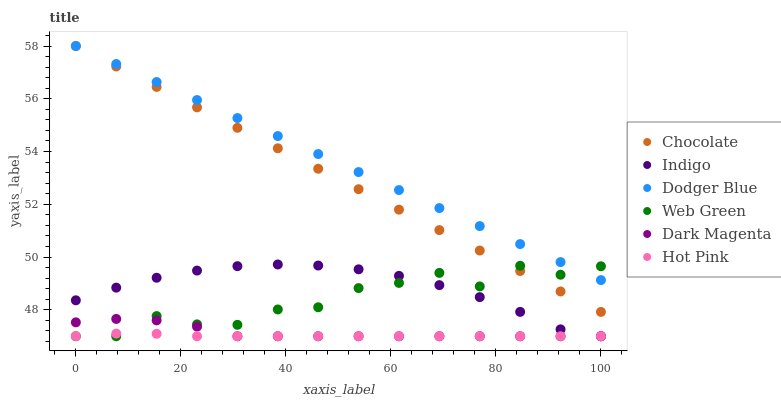Does Hot Pink have the minimum area under the curve?
Answer yes or no. Yes. Does Dodger Blue have the maximum area under the curve?
Answer yes or no. Yes. Does Dark Magenta have the minimum area under the curve?
Answer yes or no. No. Does Dark Magenta have the maximum area under the curve?
Answer yes or no. No. Is Dodger Blue the smoothest?
Answer yes or no. Yes. Is Web Green the roughest?
Answer yes or no. Yes. Is Dark Magenta the smoothest?
Answer yes or no. No. Is Dark Magenta the roughest?
Answer yes or no. No. Does Indigo have the lowest value?
Answer yes or no. Yes. Does Chocolate have the lowest value?
Answer yes or no. No. Does Dodger Blue have the highest value?
Answer yes or no. Yes. Does Dark Magenta have the highest value?
Answer yes or no. No. Is Hot Pink less than Chocolate?
Answer yes or no. Yes. Is Chocolate greater than Indigo?
Answer yes or no. Yes. Does Hot Pink intersect Dark Magenta?
Answer yes or no. Yes. Is Hot Pink less than Dark Magenta?
Answer yes or no. No. Is Hot Pink greater than Dark Magenta?
Answer yes or no. No. Does Hot Pink intersect Chocolate?
Answer yes or no. No. 